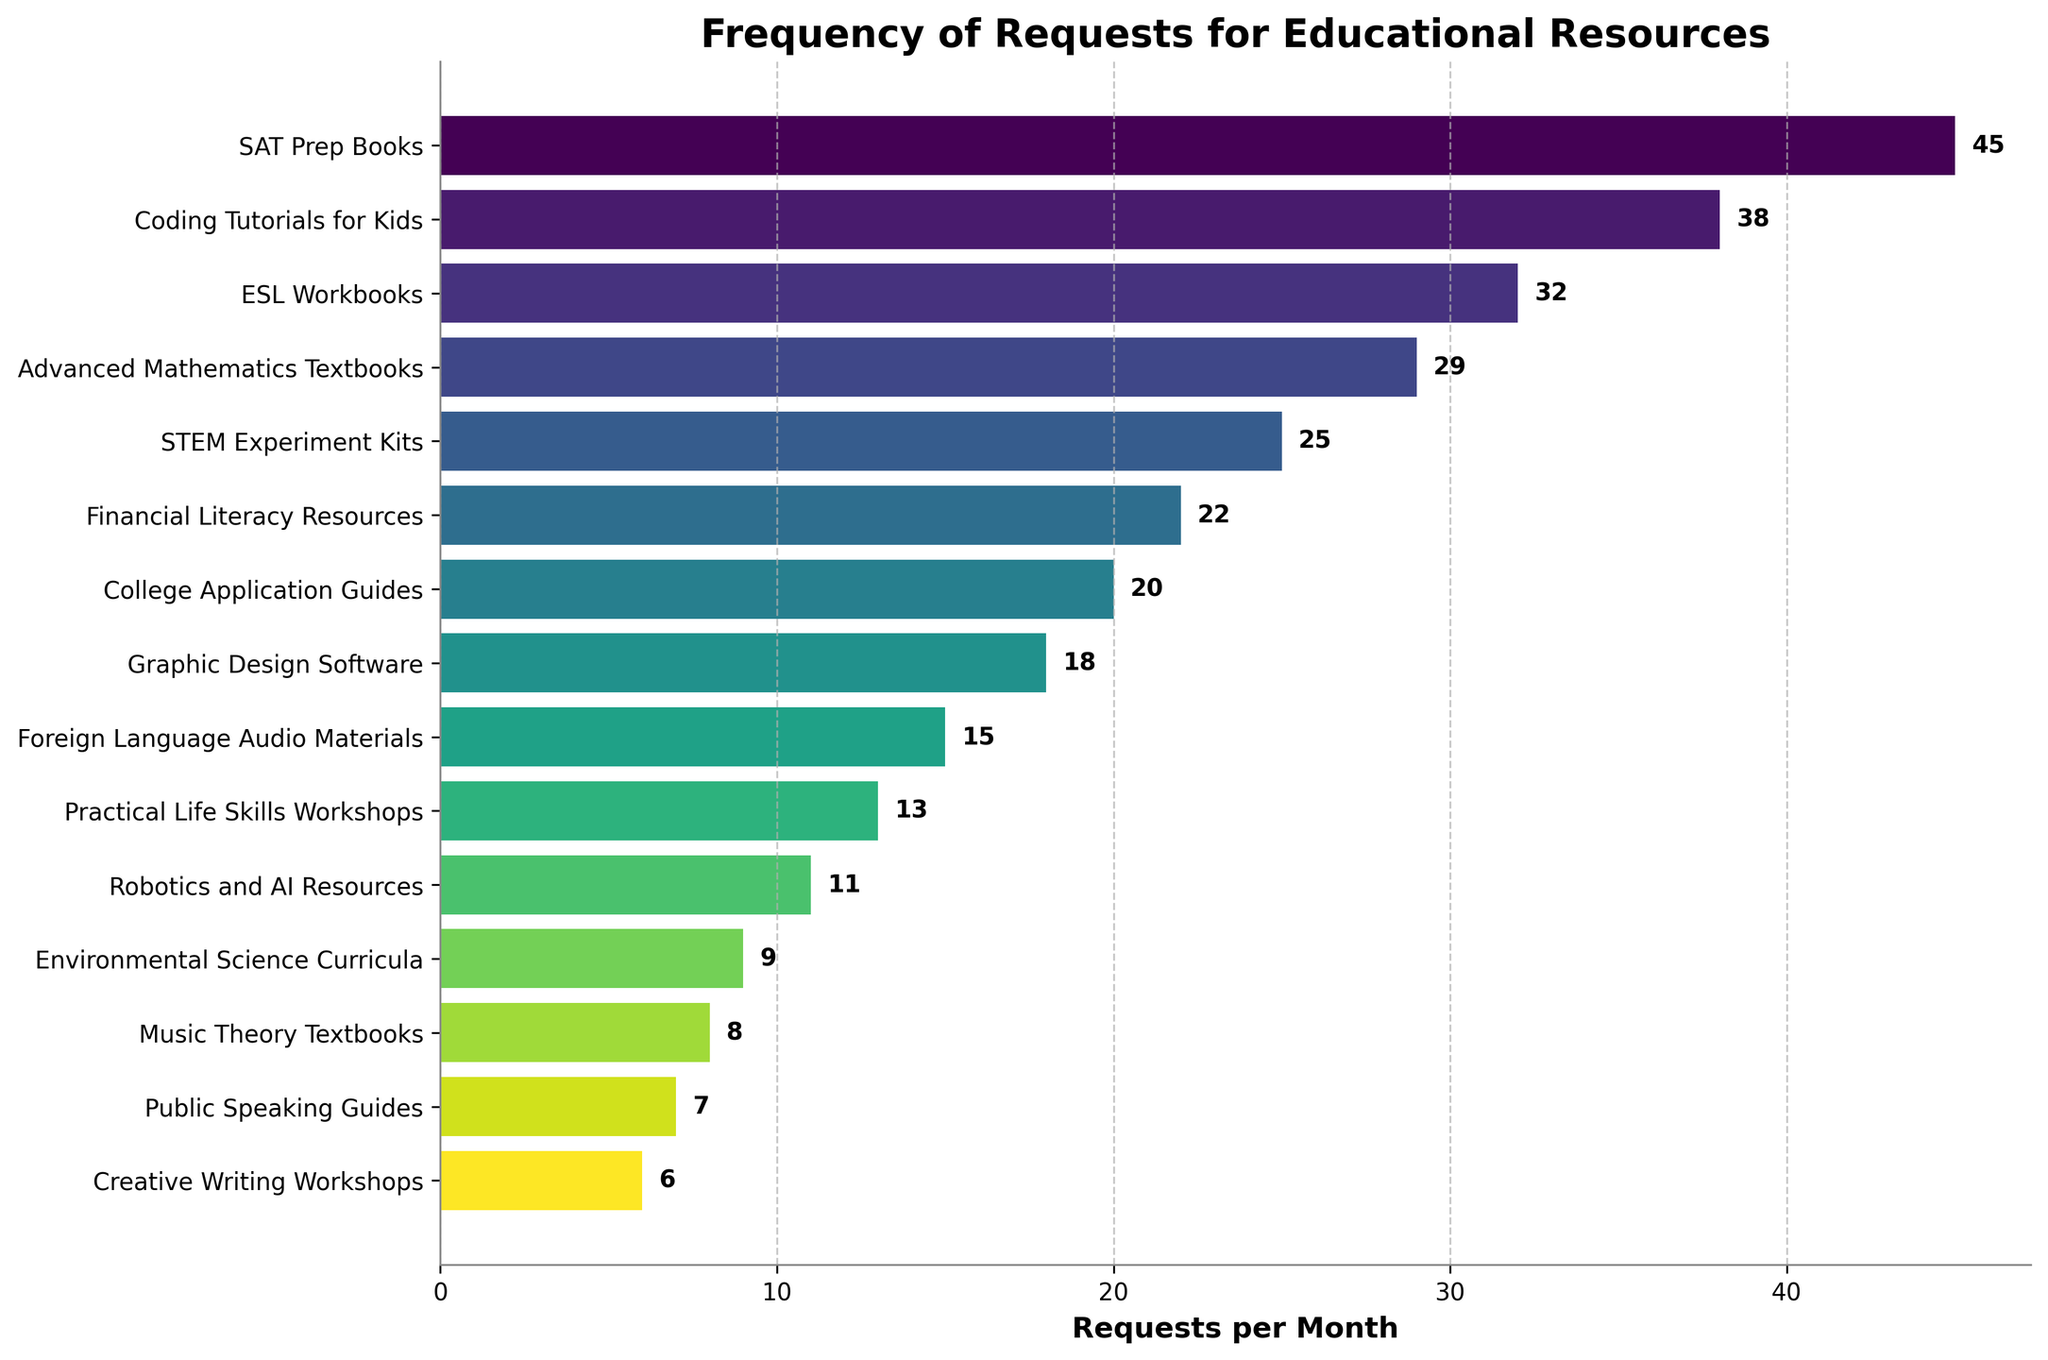Which educational resource has the highest number of requests per month? The educational resource with the highest number of requests per month is the one with the longest bar in the figure. From the figure, the longest bar corresponds to "SAT Prep Books" with 45 requests.
Answer: SAT Prep Books How many more requests per month does "Financial Literacy Resources" have compared to "Public Speaking Guides"? Identify the bars for "Financial Literacy Resources" and "Public Speaking Guides". "Financial Literacy Resources" has 22 requests, and "Public Speaking Guides" has 7. Subtract the smaller value from the larger one: 22 - 7 = 15.
Answer: 15 What is the total number of requests per month for "Advanced Mathematics Textbooks", "STEM Experiment Kits", and "Coding Tutorials for Kids" combined? Add the requests for each of the resources: "Advanced Mathematics Textbooks" (29) + "STEM Experiment Kits" (25) + "Coding Tutorials for Kids" (38). The total is 29 + 25 + 38 = 92.
Answer: 92 Which resource has fewer monthly requests, "Music Theory Textbooks" or "Creative Writing Workshops", and by how many? Find the bars for "Music Theory Textbooks" and "Creative Writing Workshops". "Music Theory Textbooks" has 8 requests, and "Creative Writing Workshops" has 6. Subtract the smaller value from the larger: 8 - 6 = 2.
Answer: Creative Writing Workshops, 2 Which educational resources have fewer than 10 requests per month? Locate the bars with values less than 10 requests per month. From the figure, these are "Environmental Science Curricula" (9), "Music Theory Textbooks" (8), "Public Speaking Guides" (7), "Creative Writing Workshops" (6), and "Robotics and AI Resources" (11). Since "Robotics and AI Resources" doesn't meet the criteria, exclude it.
Answer: Environmental Science Curricula, Music Theory Textbooks, Public Speaking Guides, Creative Writing Workshops What is the difference between the highest and the lowest number of requests per month? Identify the bar with the highest requests, which is "SAT Prep Books" (45), and the bar with the lowest requests, which is "Creative Writing Workshops" (6). Subtract the lowest value from the highest: 45 - 6 = 39.
Answer: 39 On average, how many requests per month are made for "Financial Literacy Resources", "College Application Guides", and "Graphic Design Software"? Add the requests for each resource: "Financial Literacy Resources" (22), "College Application Guides" (20), and "Graphic Design Software" (18). Sum these values and divide by the number of resources: (22 + 20 + 18) / 3 = 60 / 3 = 20.
Answer: 20 